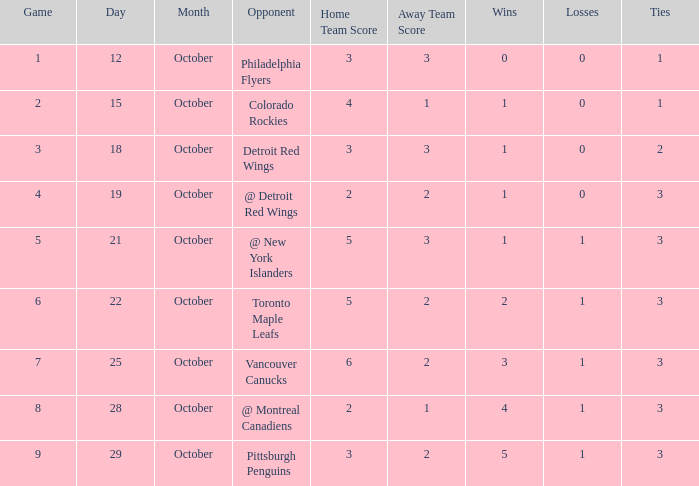Name the least game for record of 5-1-3 9.0. Could you parse the entire table as a dict? {'header': ['Game', 'Day', 'Month', 'Opponent', 'Home Team Score', 'Away Team Score', 'Wins', 'Losses', 'Ties'], 'rows': [['1', '12', 'October', 'Philadelphia Flyers', '3', '3', '0', '0', '1'], ['2', '15', 'October', 'Colorado Rockies', '4', '1', '1', '0', '1'], ['3', '18', 'October', 'Detroit Red Wings', '3', '3', '1', '0', '2'], ['4', '19', 'October', '@ Detroit Red Wings', '2', '2', '1', '0', '3'], ['5', '21', 'October', '@ New York Islanders', '5', '3', '1', '1', '3'], ['6', '22', 'October', 'Toronto Maple Leafs', '5', '2', '2', '1', '3'], ['7', '25', 'October', 'Vancouver Canucks', '6', '2', '3', '1', '3'], ['8', '28', 'October', '@ Montreal Canadiens', '2', '1', '4', '1', '3'], ['9', '29', 'October', 'Pittsburgh Penguins', '3', '2', '5', '1', '3']]} 